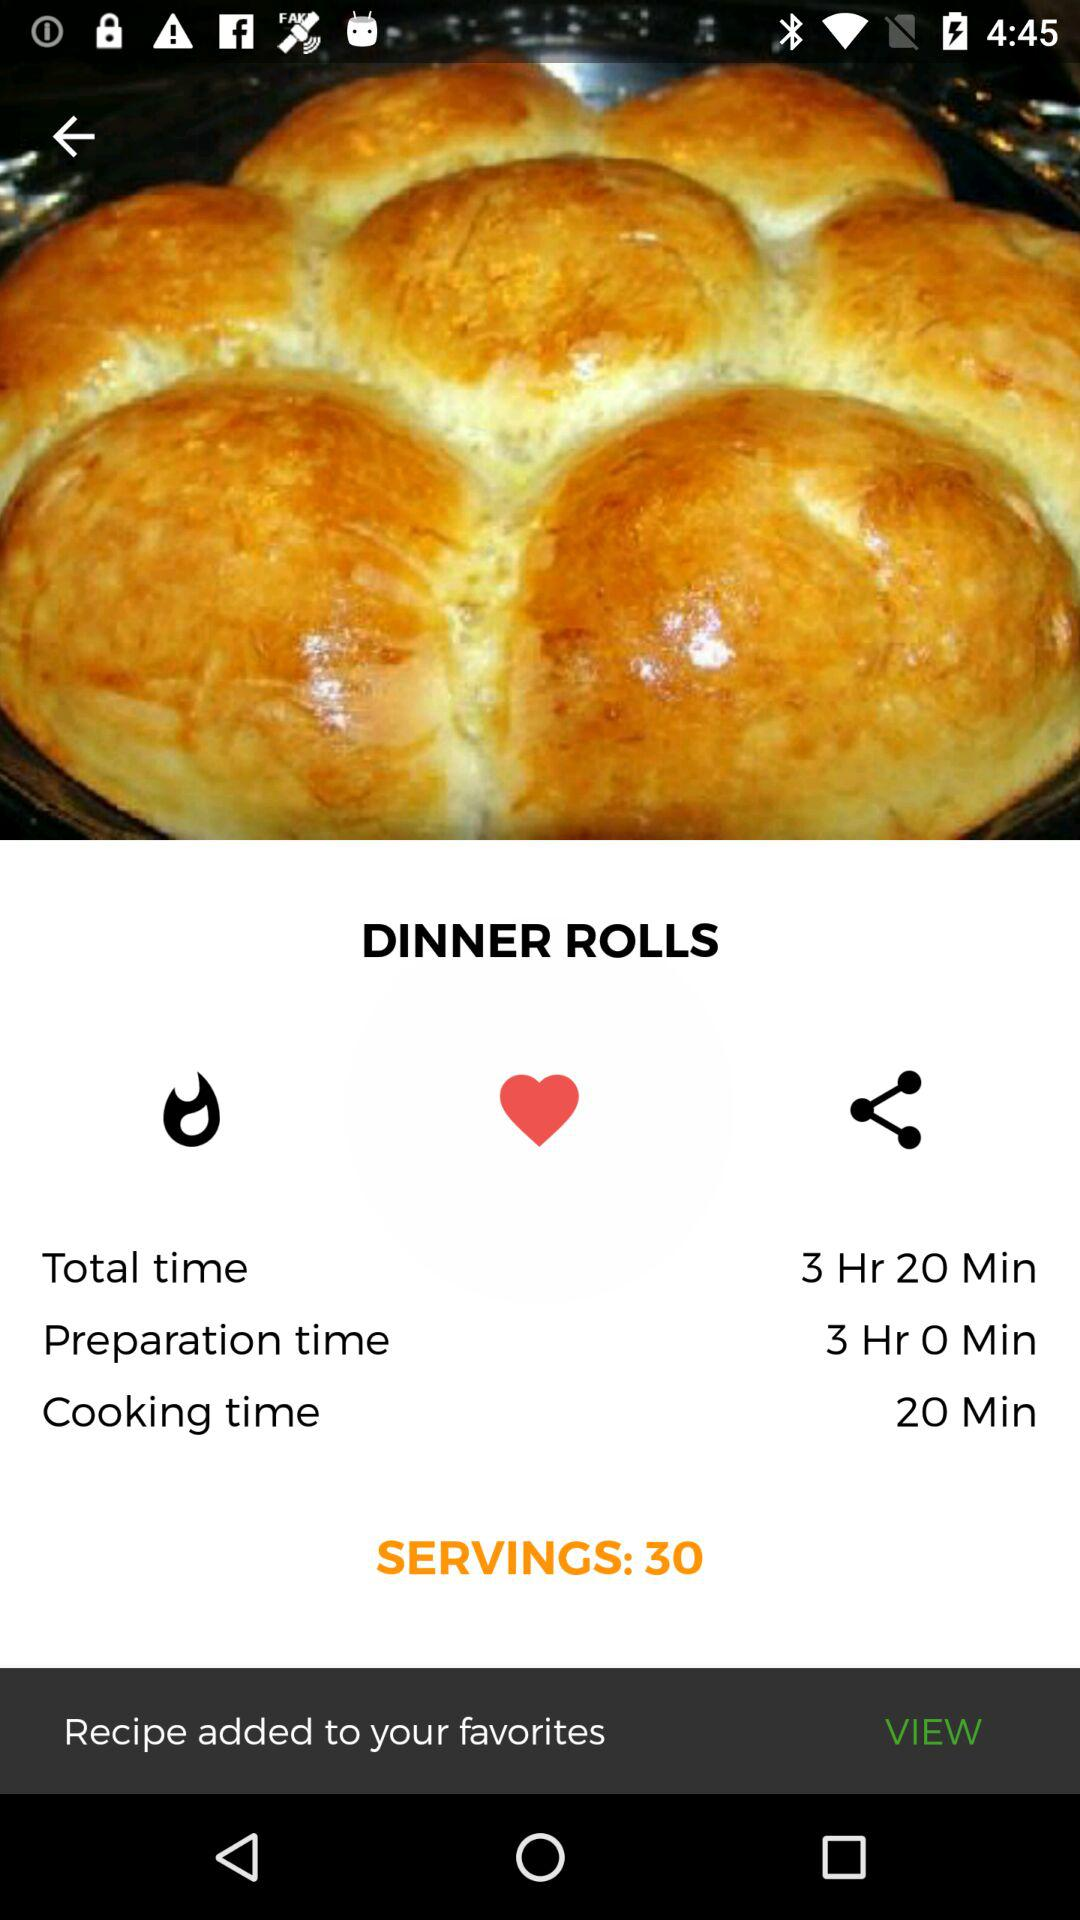What is the preparation time of dinner rolls? The preparation time of dinner rolls is 3 hours. 